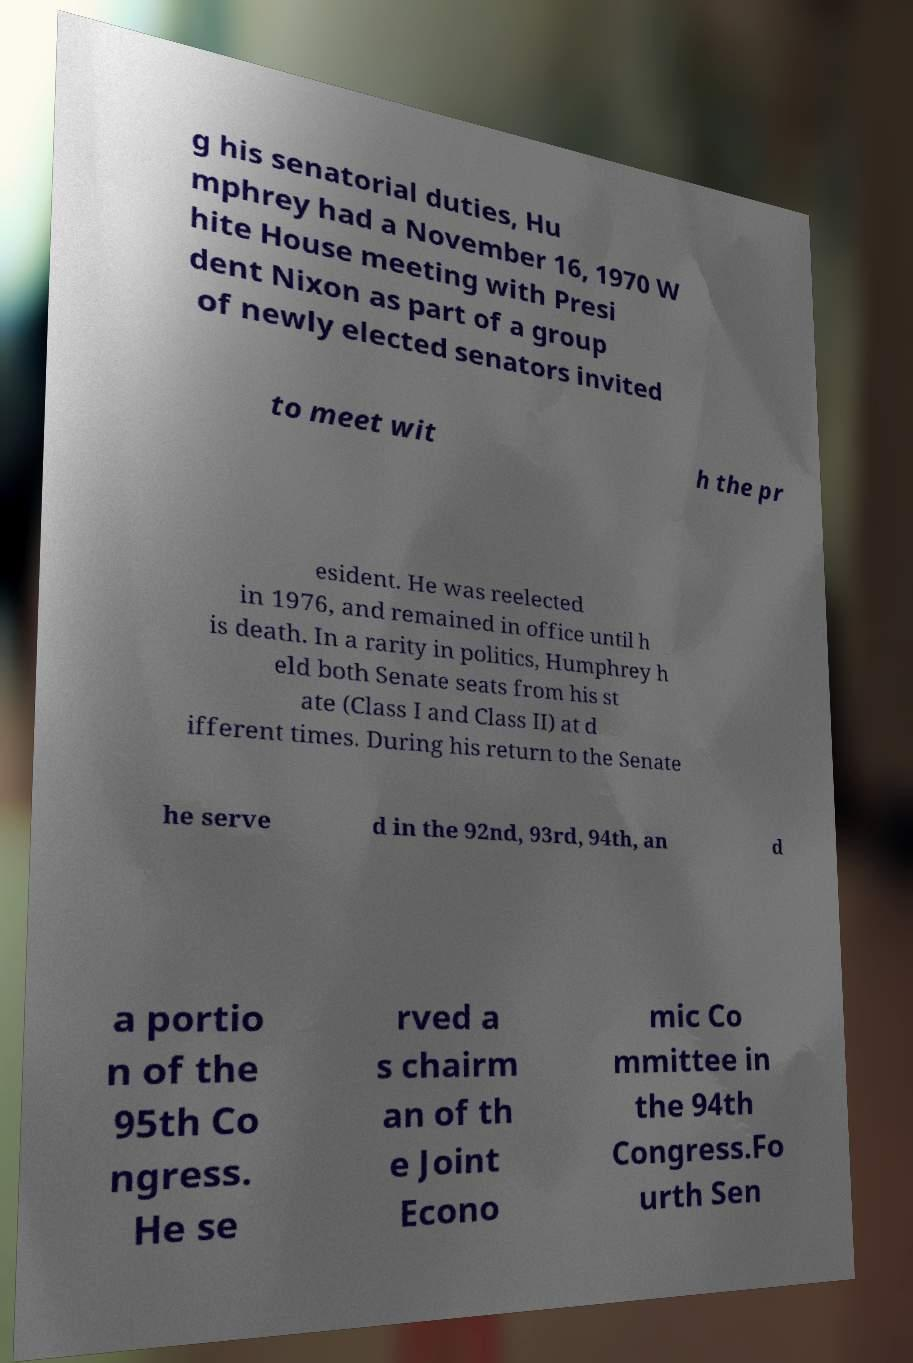For documentation purposes, I need the text within this image transcribed. Could you provide that? g his senatorial duties, Hu mphrey had a November 16, 1970 W hite House meeting with Presi dent Nixon as part of a group of newly elected senators invited to meet wit h the pr esident. He was reelected in 1976, and remained in office until h is death. In a rarity in politics, Humphrey h eld both Senate seats from his st ate (Class I and Class II) at d ifferent times. During his return to the Senate he serve d in the 92nd, 93rd, 94th, an d a portio n of the 95th Co ngress. He se rved a s chairm an of th e Joint Econo mic Co mmittee in the 94th Congress.Fo urth Sen 